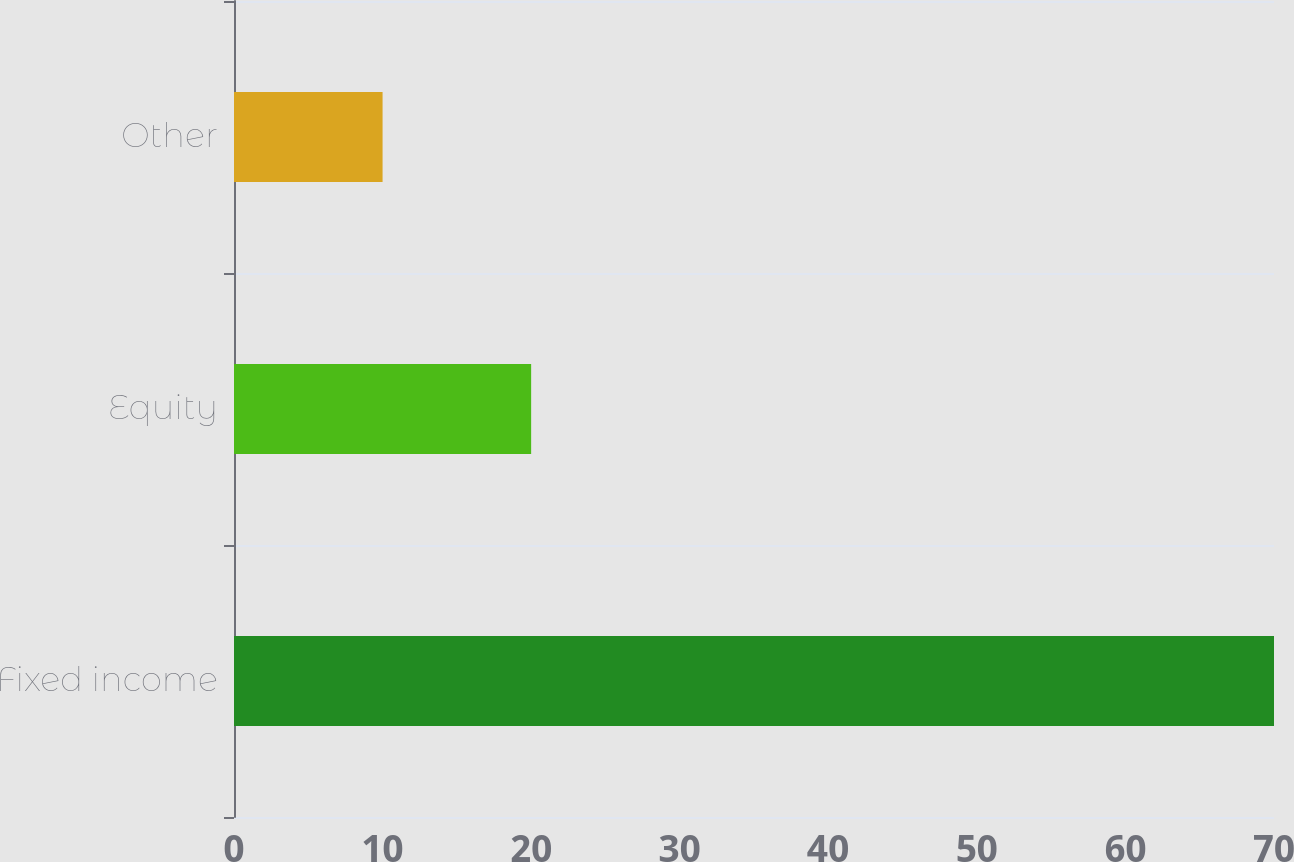Convert chart to OTSL. <chart><loc_0><loc_0><loc_500><loc_500><bar_chart><fcel>Fixed income<fcel>Equity<fcel>Other<nl><fcel>70<fcel>20<fcel>10<nl></chart> 